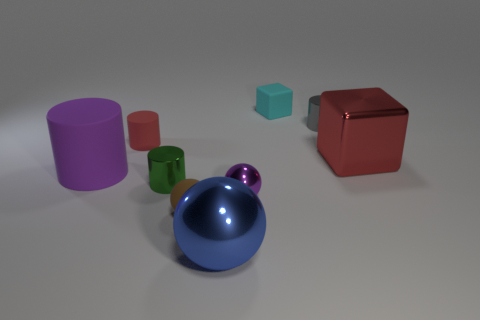What is the size of the cylinder that is the same color as the big block? The cylinder that shares its color with the large block is the small one. 